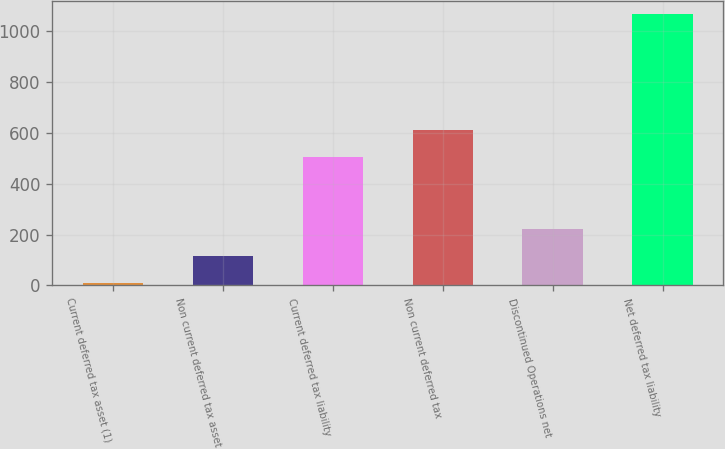<chart> <loc_0><loc_0><loc_500><loc_500><bar_chart><fcel>Current deferred tax asset (1)<fcel>Non current deferred tax asset<fcel>Current deferred tax liability<fcel>Non current deferred tax<fcel>Discontinued Operations net<fcel>Net deferred tax liability<nl><fcel>8.2<fcel>114.13<fcel>506.6<fcel>612.53<fcel>220.06<fcel>1067.5<nl></chart> 